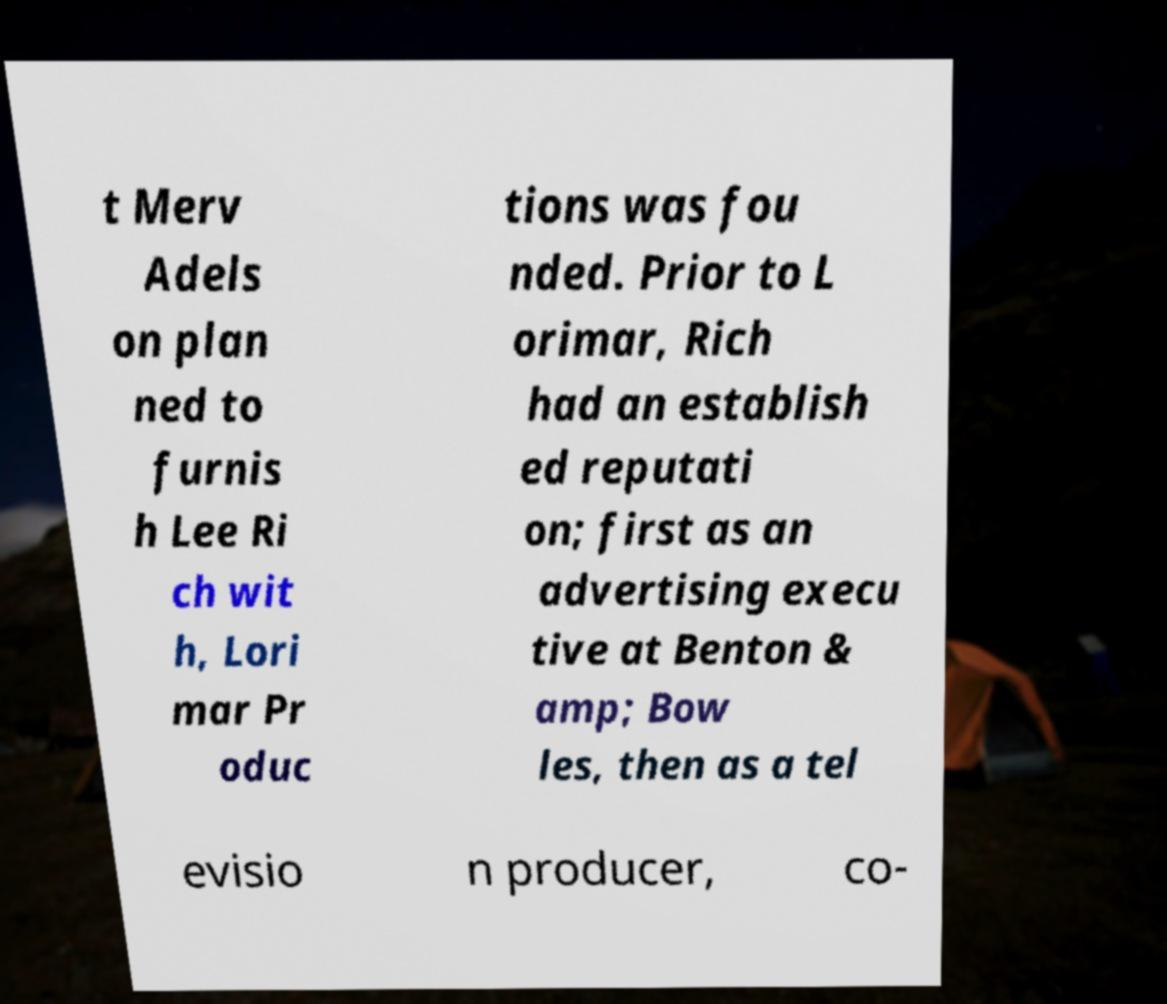There's text embedded in this image that I need extracted. Can you transcribe it verbatim? t Merv Adels on plan ned to furnis h Lee Ri ch wit h, Lori mar Pr oduc tions was fou nded. Prior to L orimar, Rich had an establish ed reputati on; first as an advertising execu tive at Benton & amp; Bow les, then as a tel evisio n producer, co- 